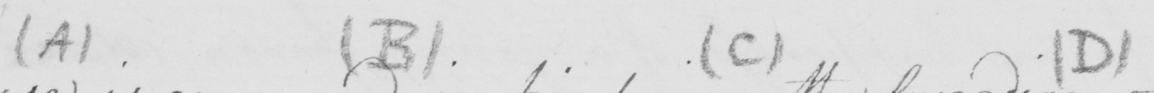Can you read and transcribe this handwriting? ( A )   ( B )   ( C )   ( D 